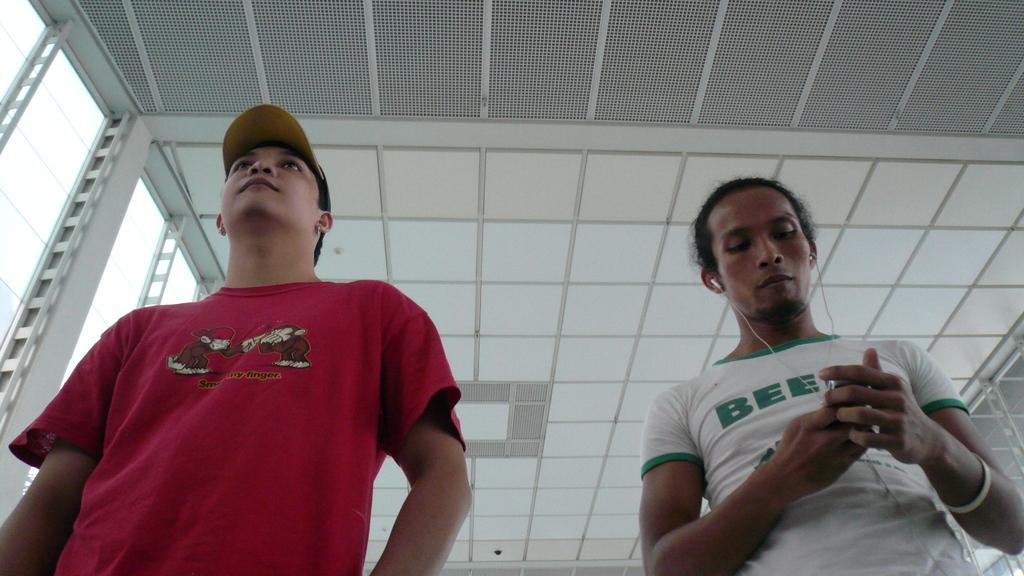Can you describe this image briefly? In this picture, we can see a few people, and among them a person with headphones is holding an object, and we can see the roof, and poles. 